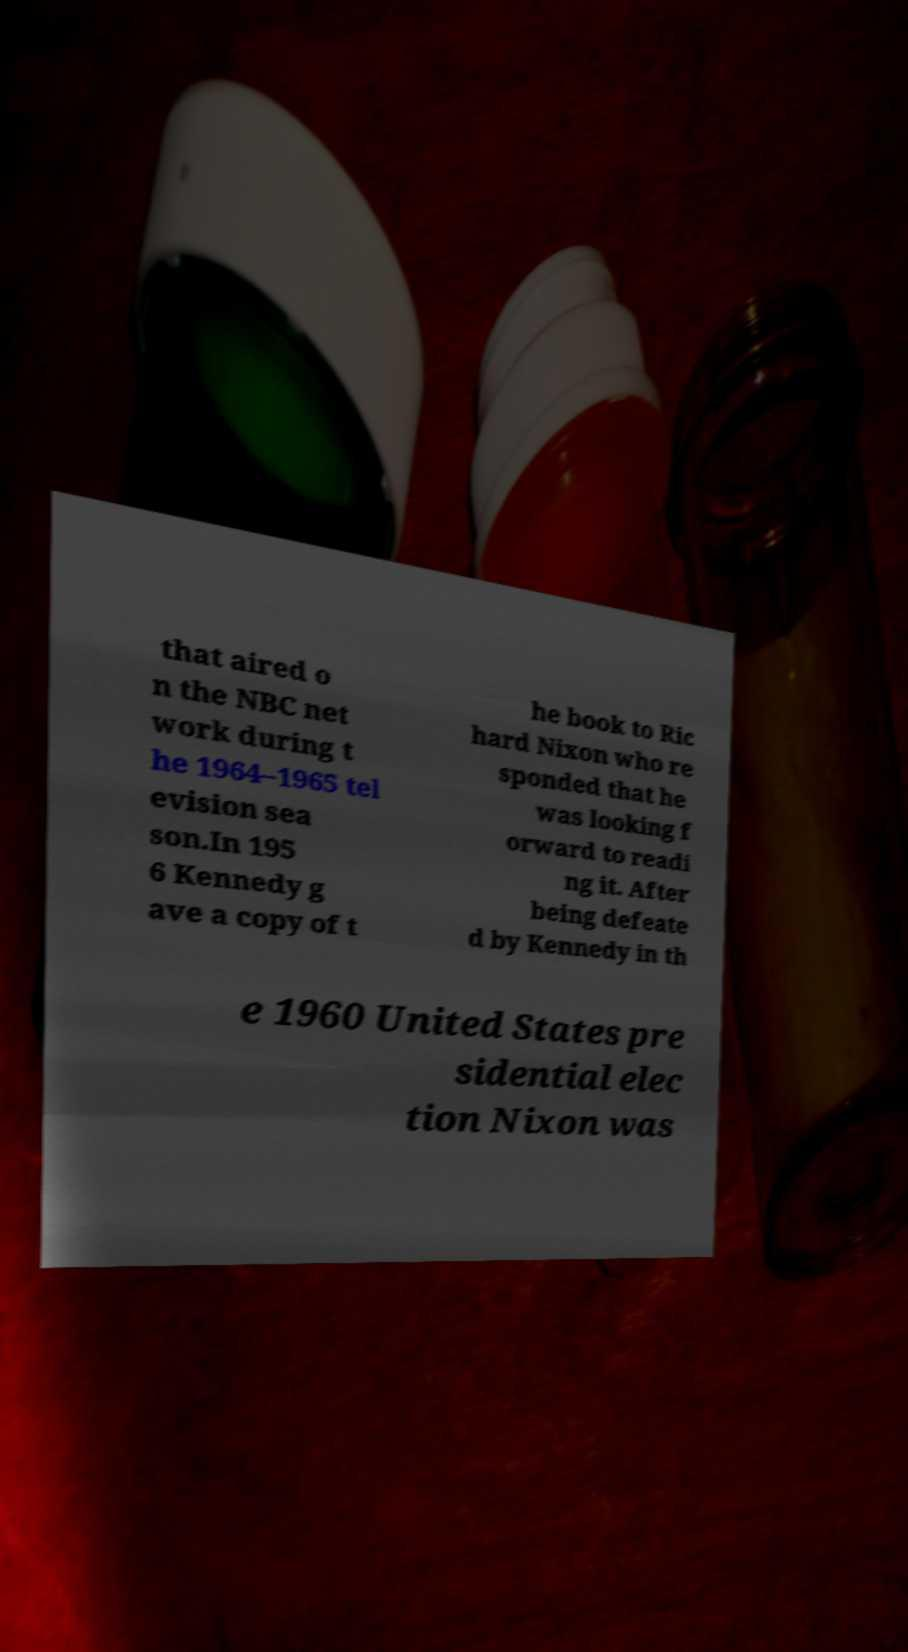I need the written content from this picture converted into text. Can you do that? that aired o n the NBC net work during t he 1964–1965 tel evision sea son.In 195 6 Kennedy g ave a copy of t he book to Ric hard Nixon who re sponded that he was looking f orward to readi ng it. After being defeate d by Kennedy in th e 1960 United States pre sidential elec tion Nixon was 